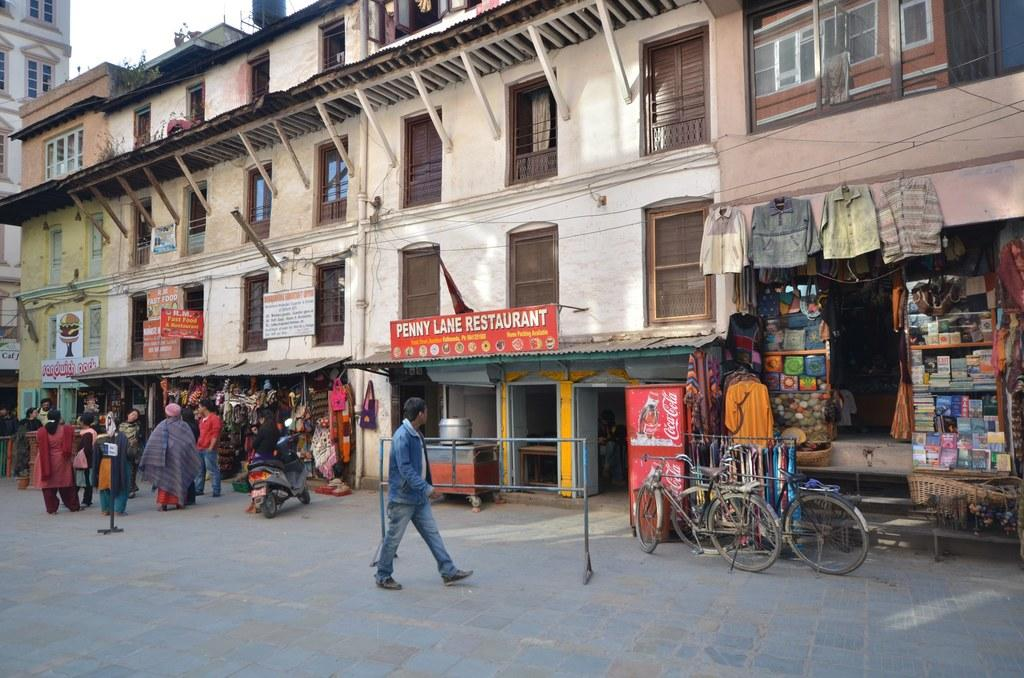Provide a one-sentence caption for the provided image. an outdoor shopping area with penny lane restaurant in the middle. 